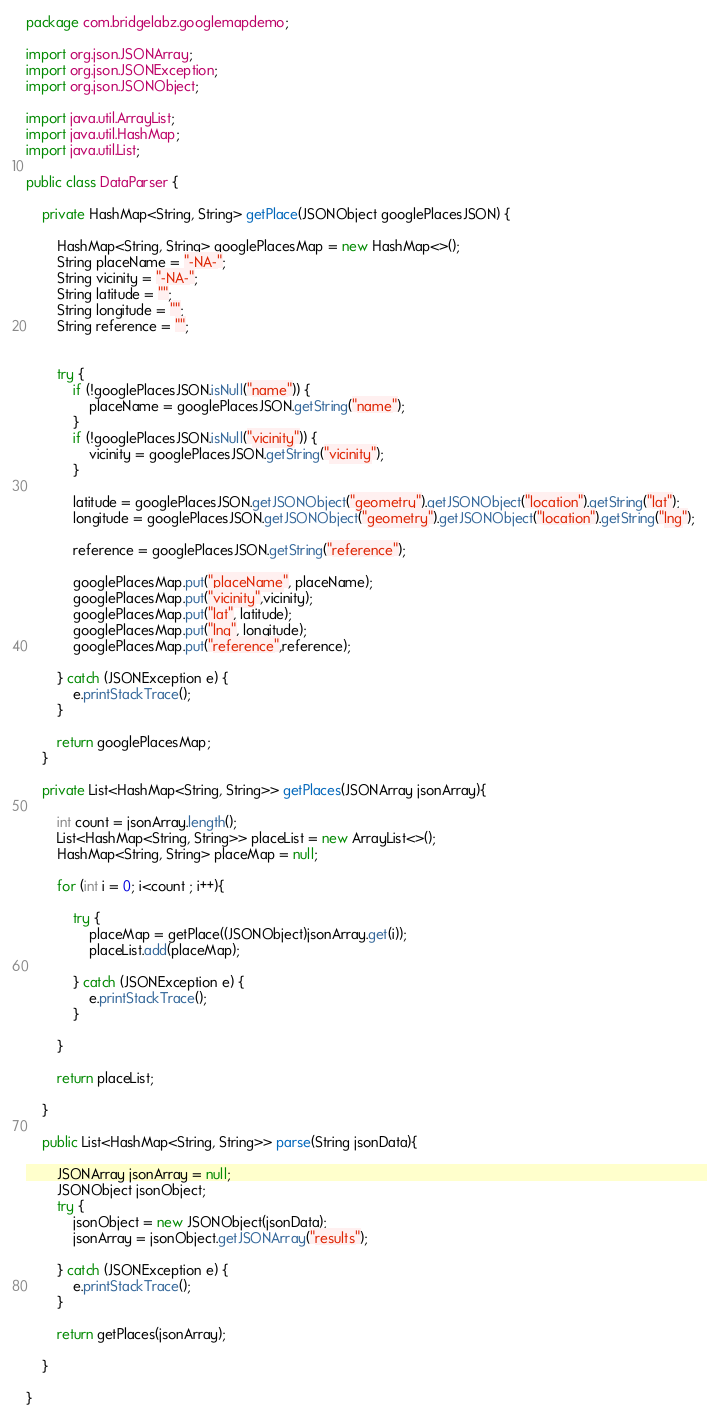Convert code to text. <code><loc_0><loc_0><loc_500><loc_500><_Java_>package com.bridgelabz.googlemapdemo;

import org.json.JSONArray;
import org.json.JSONException;
import org.json.JSONObject;

import java.util.ArrayList;
import java.util.HashMap;
import java.util.List;

public class DataParser {

    private HashMap<String, String> getPlace(JSONObject googlePlacesJSON) {

        HashMap<String, String> googlePlacesMap = new HashMap<>();
        String placeName = "-NA-";
        String vicinity = "-NA-";
        String latitude = "";
        String longitude = "";
        String reference = "";


        try {
            if (!googlePlacesJSON.isNull("name")) {
                placeName = googlePlacesJSON.getString("name");
            }
            if (!googlePlacesJSON.isNull("vicinity")) {
                vicinity = googlePlacesJSON.getString("vicinity");
            }

            latitude = googlePlacesJSON.getJSONObject("geometry").getJSONObject("location").getString("lat");
            longitude = googlePlacesJSON.getJSONObject("geometry").getJSONObject("location").getString("lng");

            reference = googlePlacesJSON.getString("reference");

            googlePlacesMap.put("placeName", placeName);
            googlePlacesMap.put("vicinity",vicinity);
            googlePlacesMap.put("lat", latitude);
            googlePlacesMap.put("lng", longitude);
            googlePlacesMap.put("reference",reference);

        } catch (JSONException e) {
            e.printStackTrace();
        }

        return googlePlacesMap;
    }

    private List<HashMap<String, String>> getPlaces(JSONArray jsonArray){

        int count = jsonArray.length();
        List<HashMap<String, String>> placeList = new ArrayList<>();
        HashMap<String, String> placeMap = null;

        for (int i = 0; i<count ; i++){

            try {
                placeMap = getPlace((JSONObject)jsonArray.get(i));
                placeList.add(placeMap);

            } catch (JSONException e) {
                e.printStackTrace();
            }

        }

        return placeList;

    }

    public List<HashMap<String, String>> parse(String jsonData){

        JSONArray jsonArray = null;
        JSONObject jsonObject;
        try {
            jsonObject = new JSONObject(jsonData);
            jsonArray = jsonObject.getJSONArray("results");

        } catch (JSONException e) {
            e.printStackTrace();
        }

        return getPlaces(jsonArray);

    }

}
</code> 